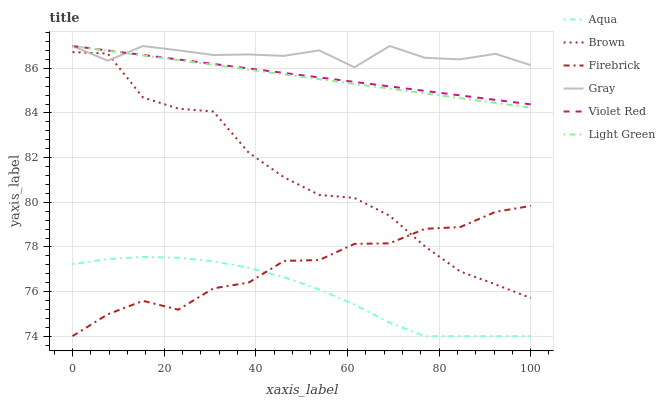Does Aqua have the minimum area under the curve?
Answer yes or no. Yes. Does Gray have the maximum area under the curve?
Answer yes or no. Yes. Does Violet Red have the minimum area under the curve?
Answer yes or no. No. Does Violet Red have the maximum area under the curve?
Answer yes or no. No. Is Violet Red the smoothest?
Answer yes or no. Yes. Is Brown the roughest?
Answer yes or no. Yes. Is Gray the smoothest?
Answer yes or no. No. Is Gray the roughest?
Answer yes or no. No. Does Aqua have the lowest value?
Answer yes or no. Yes. Does Violet Red have the lowest value?
Answer yes or no. No. Does Light Green have the highest value?
Answer yes or no. Yes. Does Firebrick have the highest value?
Answer yes or no. No. Is Brown less than Violet Red?
Answer yes or no. Yes. Is Gray greater than Firebrick?
Answer yes or no. Yes. Does Light Green intersect Gray?
Answer yes or no. Yes. Is Light Green less than Gray?
Answer yes or no. No. Is Light Green greater than Gray?
Answer yes or no. No. Does Brown intersect Violet Red?
Answer yes or no. No. 